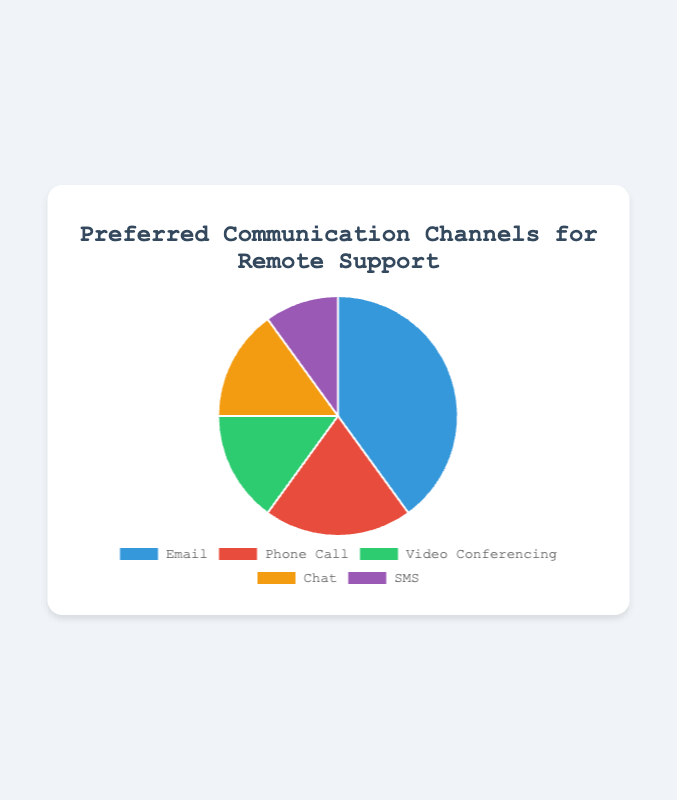What is the most preferred communication channel for remote support in the pie chart? The pie chart shows different communication channels with their percentage. The highest percentage represents the most preferred channel. In this chart, Email has the highest percentage at 40%.
Answer: Email Which communication channels are equally preferred according to the pie chart? To determine which channels are equally preferred, we look for channels with the same percentage in the pie chart. Both Video Conferencing and Chat have a percentage of 15%.
Answer: Video Conferencing and Chat How many percentage points more preferred is Email than SMS? To find out how many percentage points more one channel is preferred over another, subtract the smaller percentage from the larger percentage. Email is 40%, and SMS is 10%. 40% - 10% = 30%.
Answer: 30% What is the combined percentage of Phone Call and SMS? To get the combined percentage of two channels, add their respective percentages together. Phone Call is 20% and SMS is 10%, so 20% + 10% = 30%.
Answer: 30% If we combine all the communication channels except for Email, what percentage do they represent? Add the percentages of Phone Call, Video Conferencing, Chat, and SMS together. Phone Call (20%) + Video Conferencing (15%) + Chat (15%) + SMS (10%) = 60%.
Answer: 60% Which communication channel is represented by the green color? According to the data, Video Conferencing has a percentage of 15% and is represented by the green color on the chart.
Answer: Video Conferencing By how much does the percentage of Email exceed that of Video Conferencing and Chat combined? Combined percentage of Video Conferencing and Chat is 15% + 15% = 30%. The percentage of Email is 40%. 40% - 30% = 10%.
Answer: 10% Which channel has the smallest percentage, and what is its percentage? By looking at the pie chart, we see that SMS has the smallest segment, representing 10%.
Answer: SMS (10%) If 1,000 users were surveyed, how many preferred Email? To find the number of users who preferred Email, calculate 40% of 1,000. (40/100) * 1,000 = 400 users.
Answer: 400 How does the preference for Phone Call compare to the preference for Chat? The pie chart shows that Phone Call has a percentage of 20%, whereas Chat has a percentage of 15%. Therefore, Phone Call is more preferred than Chat.
Answer: Phone Call is more preferred 